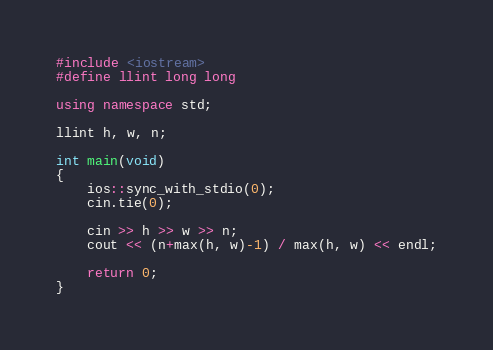<code> <loc_0><loc_0><loc_500><loc_500><_C++_>#include <iostream>
#define llint long long

using namespace std;

llint h, w, n;

int main(void)
{
	ios::sync_with_stdio(0);
	cin.tie(0);
	
	cin >> h >> w >> n;
	cout << (n+max(h, w)-1) / max(h, w) << endl;
	
	return 0;
}</code> 